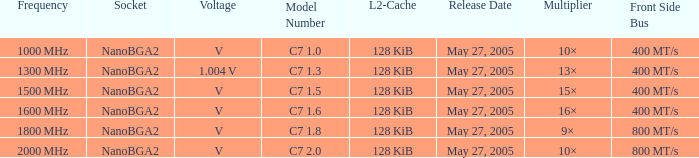Can you provide the front side bus details for the model number c7 1.5? 400 MT/s. 